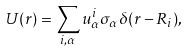Convert formula to latex. <formula><loc_0><loc_0><loc_500><loc_500>U ( r ) = \sum _ { i , \alpha } u _ { \alpha } ^ { i } \sigma _ { \alpha } \delta ( r - R _ { i } ) ,</formula> 